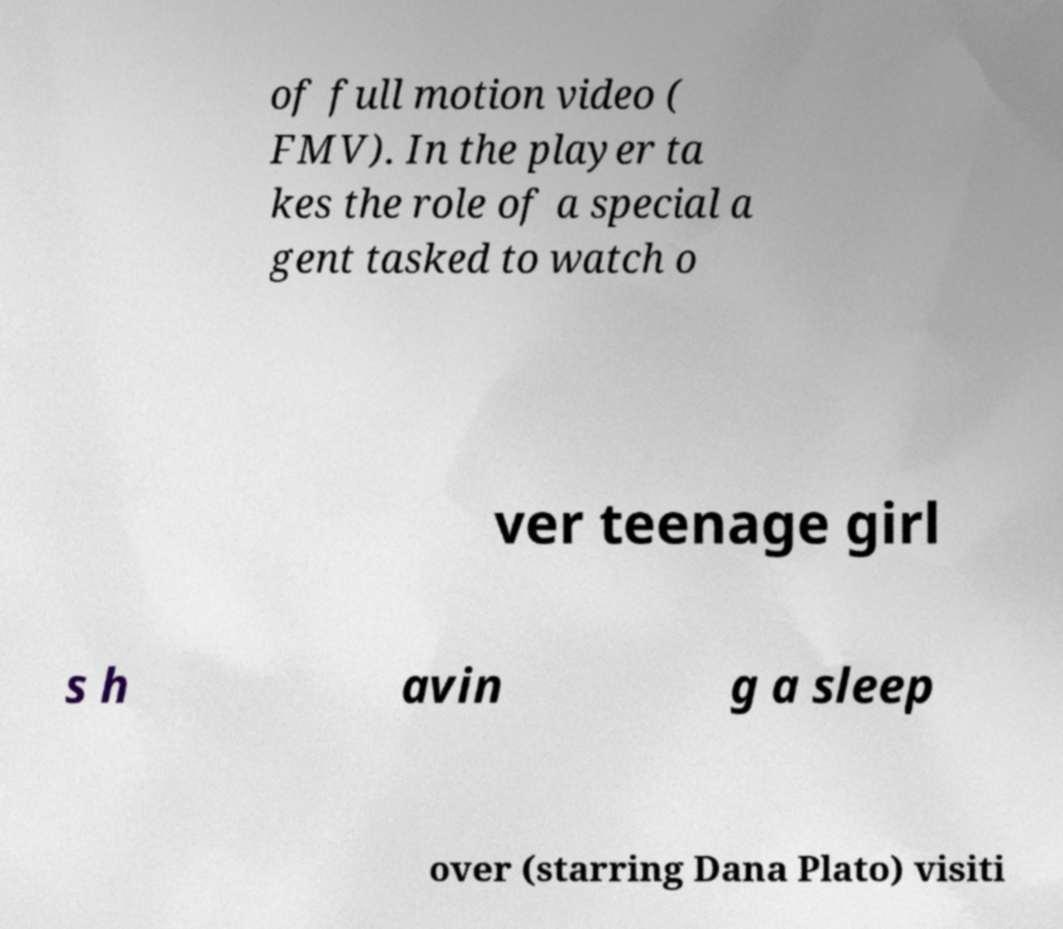What messages or text are displayed in this image? I need them in a readable, typed format. of full motion video ( FMV). In the player ta kes the role of a special a gent tasked to watch o ver teenage girl s h avin g a sleep over (starring Dana Plato) visiti 